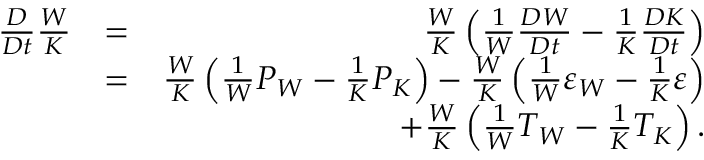<formula> <loc_0><loc_0><loc_500><loc_500>\begin{array} { r l r } { \frac { D } { D t } \frac { W } { K } } & { = } & { \frac { W } { K } \left ( { \frac { 1 } { W } \frac { D W } { D t } - \frac { 1 } { K } \frac { D K } { D t } } \right ) } \\ & { = } & { \frac { W } { K } \left ( { \frac { 1 } { W } P _ { W } - \frac { 1 } { K } P _ { K } } \right ) - \frac { W } { K } \left ( { \frac { 1 } { W } \varepsilon _ { W } - \frac { 1 } { K } \varepsilon } \right ) } \\ & { + \frac { W } { K } \left ( { \frac { 1 } { W } T _ { W } - \frac { 1 } { K } T _ { K } } \right ) . } \end{array}</formula> 